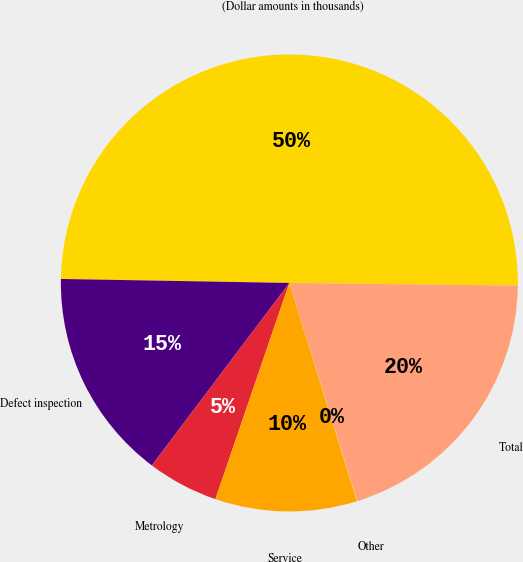Convert chart. <chart><loc_0><loc_0><loc_500><loc_500><pie_chart><fcel>(Dollar amounts in thousands)<fcel>Defect inspection<fcel>Metrology<fcel>Service<fcel>Other<fcel>Total<nl><fcel>49.9%<fcel>15.0%<fcel>5.03%<fcel>10.02%<fcel>0.05%<fcel>19.99%<nl></chart> 